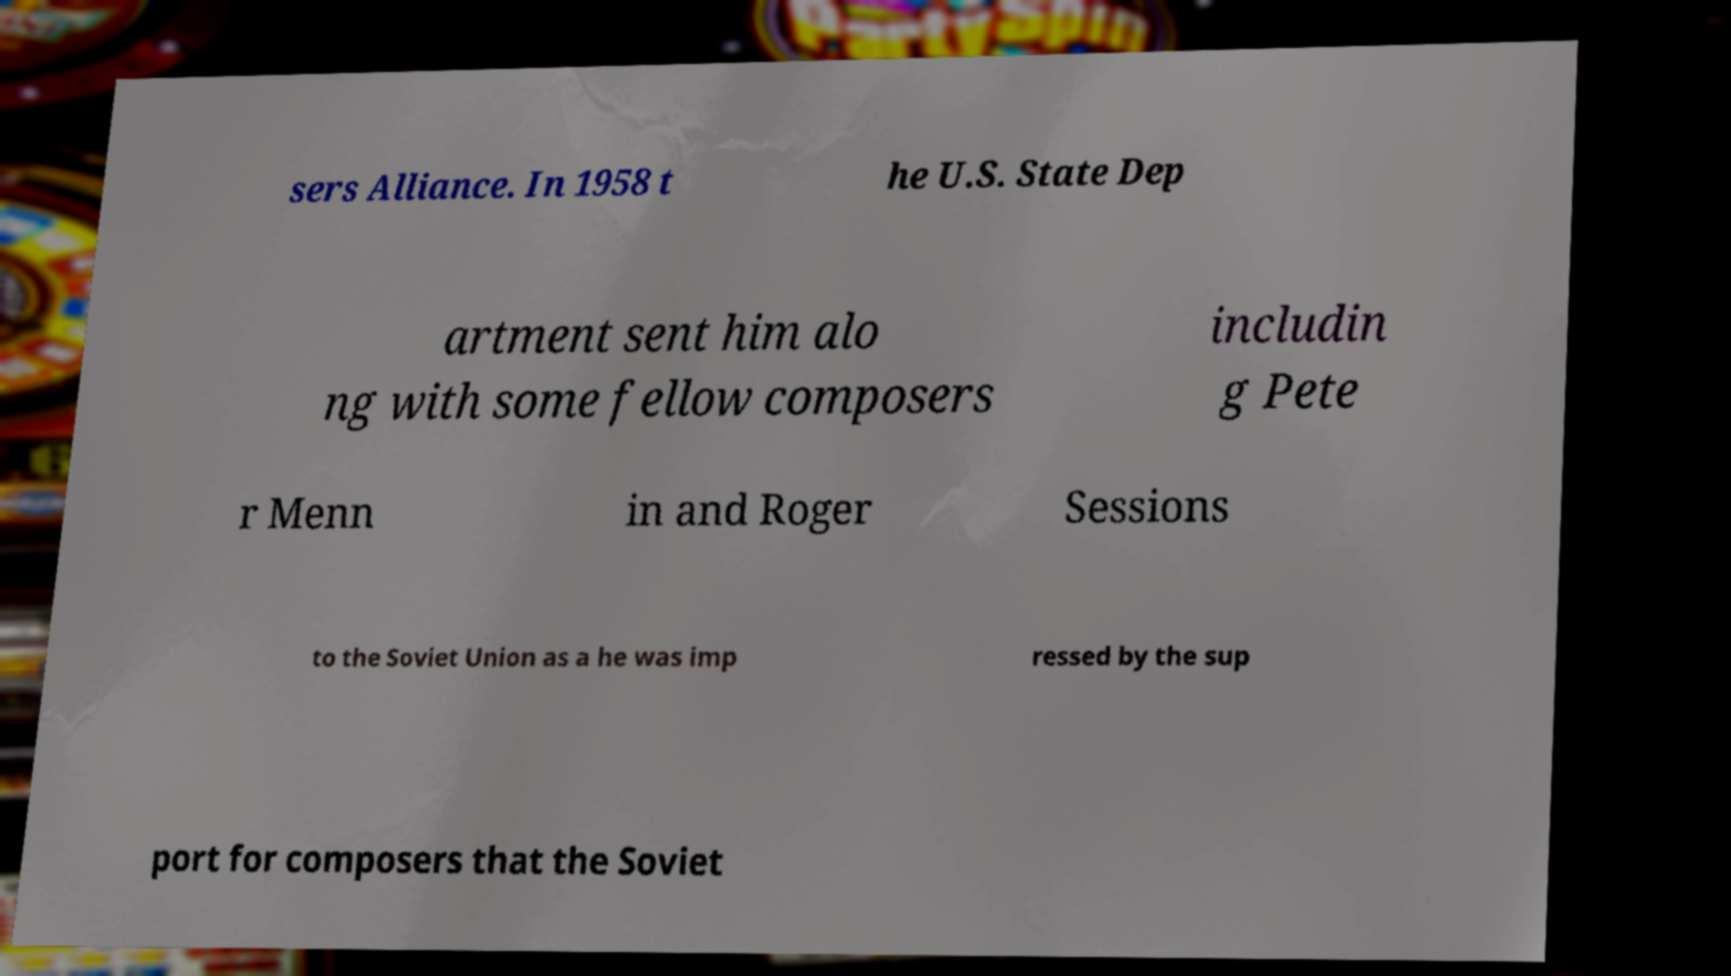Please identify and transcribe the text found in this image. sers Alliance. In 1958 t he U.S. State Dep artment sent him alo ng with some fellow composers includin g Pete r Menn in and Roger Sessions to the Soviet Union as a he was imp ressed by the sup port for composers that the Soviet 